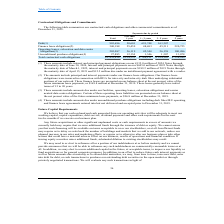According to Cogent Communications Group's financial document, What is the value of the interest and principal payment obligations included in the company's debt under 2024 Notes? According to the financial document, 135.0 million. The relevant text states: "nterest and principal payment obligations on our €135.0 million of 2024 Notes through the maturity date of June 30, 2024, interest and principal payments on our $4..." Also, What is the value of the interest and principal payment obligations included in the debt under 2022 Notes? According to the financial document, 445.0 million. The relevant text states: "30, 2024, interest and principal payments on our $445.0 million of 2022 Notes through the maturity date of March 1, 2022, interest and principal payments on our $1..." Also, What is the value of the interest and principal payment obligations included in the debt under 2021 Notes? According to the financial document, 189.2 million. The relevant text states: "1, 2022, interest and principal payments on our $189.2 million of 2021 Notes through the maturity date of April 15, 2021 and $12.5 million due under an installmen..." Also, can you calculate: What is the company's total debt due within 3 years? Based on the calculation: (50,601 + 691,748) , the result is 742349 (in thousands). This is based on the information: "- 5 years 5 years (in thousands) Debt(1) 903,696 50,601 691,748 161,347 — Finance lease obligations(2) 340,188 25,459 48,693 45,311 220,725 Operating lease ars 5 years (in thousands) Debt(1) 903,696 5..." The key data points involved are: 50,601, 691,748. Also, can you calculate: What is the company's total finance lease obligations due within 3 years? Based on the calculation: (48,693 + 25,459) , the result is 74152 (in thousands). This is based on the information: "48 161,347 — Finance lease obligations(2) 340,188 25,459 48,693 45,311 220,725 Operating leases, colocation and data center obligations(3) 205,087 36,119 42 347 — Finance lease obligations(2) 340,188 ..." The key data points involved are: 25,459, 48,693. Also, can you calculate: What is the company's unconditional purchase obligations due within 3 years? Based on the calculation: 1,346 + 12,154 , the result is 13500 (in thousands). This is based on the information: ",486 Unconditional purchase obligations(4) 27,885 12,154 1,346 1,307 13,078 Total contractual cash obligations $ 1,476,856 $ 124,333 $ 784,131 $ 234,103 $ 3 conditional purchase obligations(4) 27,885 ..." The key data points involved are: 1,346, 12,154. 